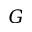Convert formula to latex. <formula><loc_0><loc_0><loc_500><loc_500>{ G }</formula> 